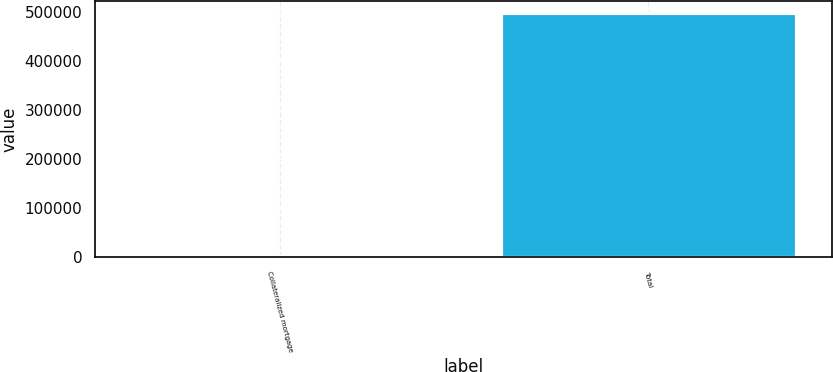Convert chart to OTSL. <chart><loc_0><loc_0><loc_500><loc_500><bar_chart><fcel>Collateralized mortgage<fcel>Total<nl><fcel>1567<fcel>498526<nl></chart> 